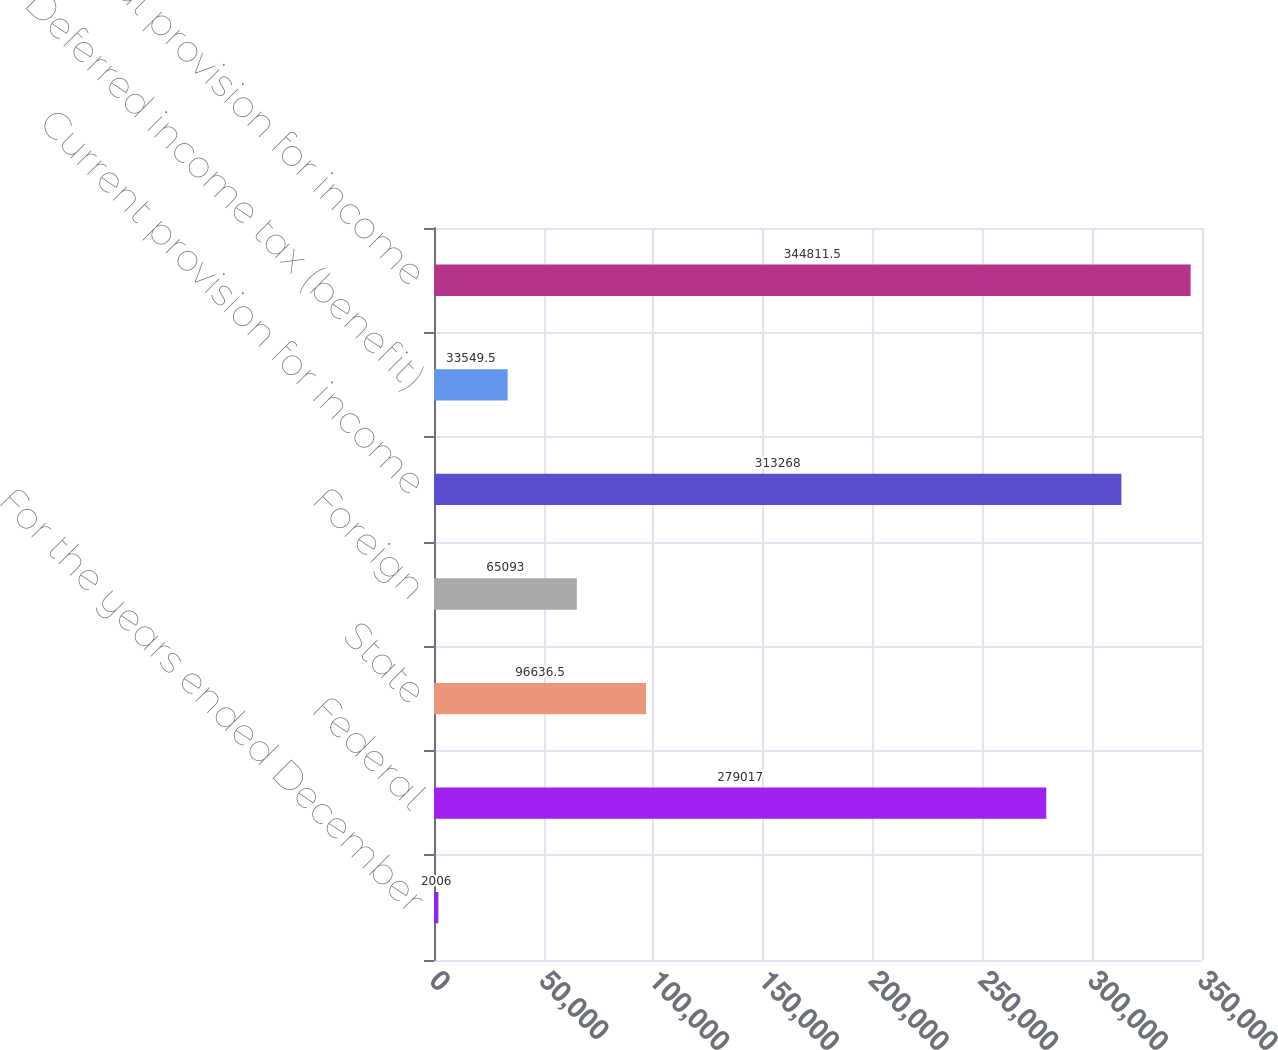Convert chart. <chart><loc_0><loc_0><loc_500><loc_500><bar_chart><fcel>For the years ended December<fcel>Federal<fcel>State<fcel>Foreign<fcel>Current provision for income<fcel>Deferred income tax (benefit)<fcel>Total provision for income<nl><fcel>2006<fcel>279017<fcel>96636.5<fcel>65093<fcel>313268<fcel>33549.5<fcel>344812<nl></chart> 